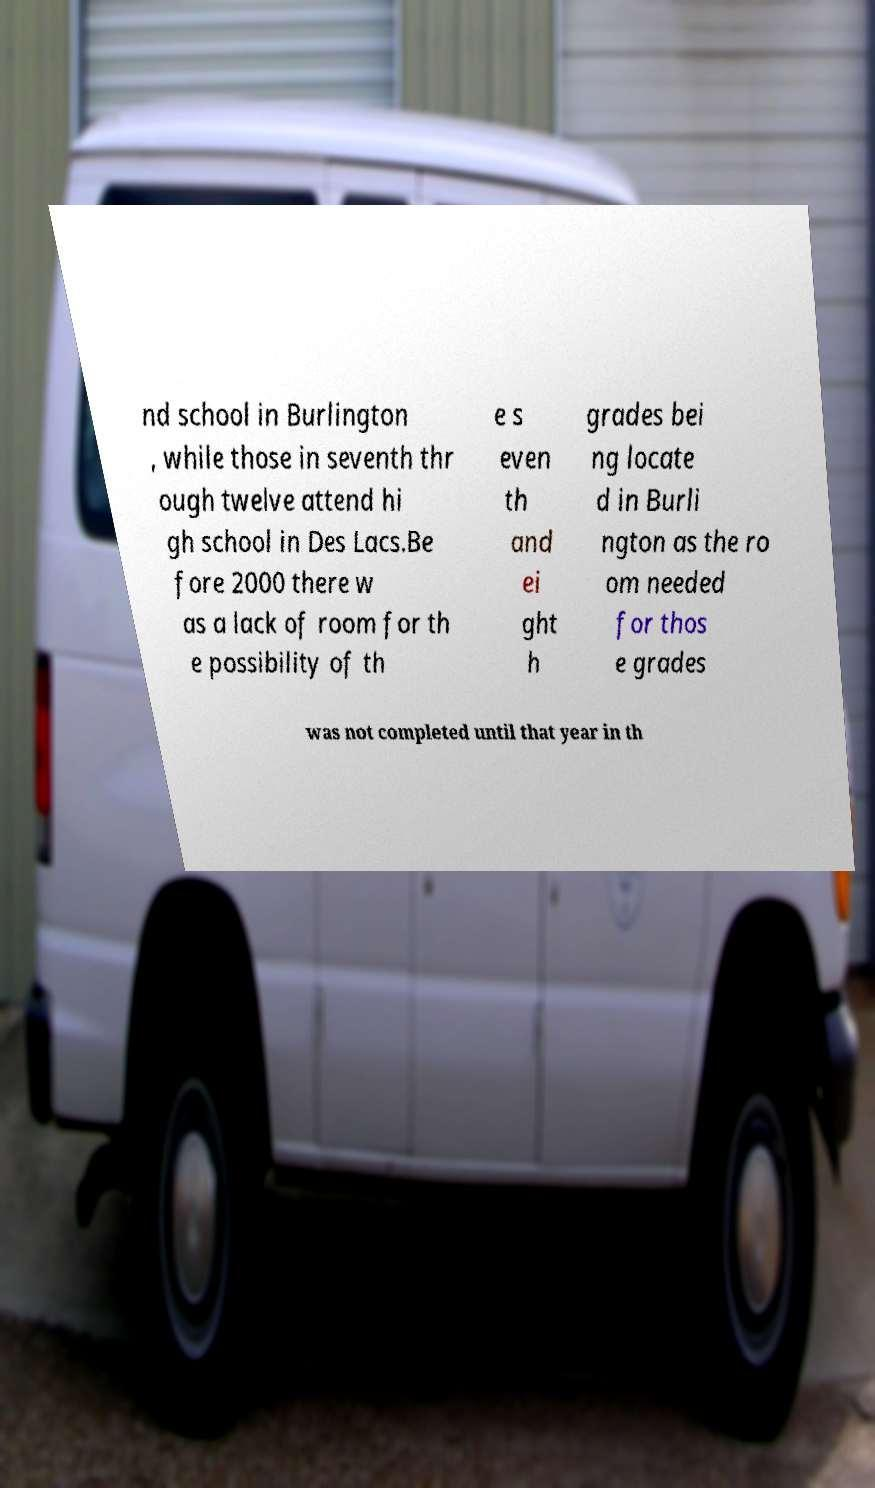What messages or text are displayed in this image? I need them in a readable, typed format. nd school in Burlington , while those in seventh thr ough twelve attend hi gh school in Des Lacs.Be fore 2000 there w as a lack of room for th e possibility of th e s even th and ei ght h grades bei ng locate d in Burli ngton as the ro om needed for thos e grades was not completed until that year in th 